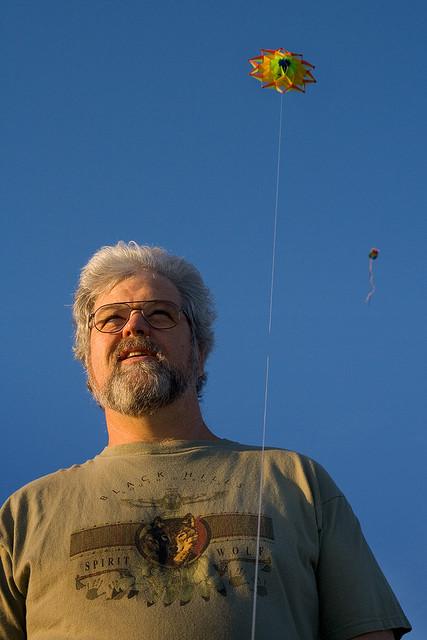What is floating over the man's head?
Quick response, please. Kite. Does the man have facial hair?
Concise answer only. Yes. What color is the kite?
Write a very short answer. Yellow. What animal is on the man's shirt?
Concise answer only. Wolf. 